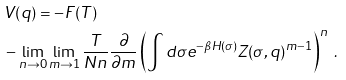<formula> <loc_0><loc_0><loc_500><loc_500>& V ( q ) = - F ( T ) \\ & - \lim _ { n \rightarrow 0 } \lim _ { m \rightarrow 1 } \frac { T } { N n } \frac { \partial } { \partial m } \left ( \int d \sigma e ^ { - \beta H ( \sigma ) } Z ( \sigma , q ) ^ { m - 1 } \right ) ^ { n } \ .</formula> 